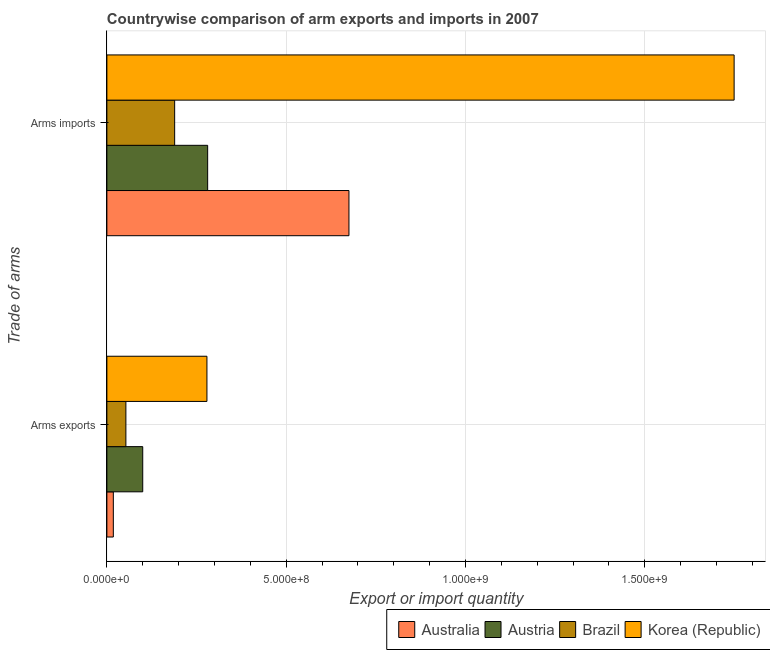How many different coloured bars are there?
Make the answer very short. 4. Are the number of bars on each tick of the Y-axis equal?
Ensure brevity in your answer.  Yes. What is the label of the 2nd group of bars from the top?
Your response must be concise. Arms exports. What is the arms imports in Australia?
Ensure brevity in your answer.  6.75e+08. Across all countries, what is the maximum arms exports?
Offer a terse response. 2.79e+08. Across all countries, what is the minimum arms imports?
Keep it short and to the point. 1.89e+08. What is the total arms imports in the graph?
Your answer should be compact. 2.89e+09. What is the difference between the arms imports in Brazil and that in Korea (Republic)?
Make the answer very short. -1.56e+09. What is the difference between the arms imports in Korea (Republic) and the arms exports in Brazil?
Your answer should be compact. 1.70e+09. What is the average arms exports per country?
Your answer should be compact. 1.12e+08. What is the difference between the arms imports and arms exports in Brazil?
Offer a terse response. 1.36e+08. In how many countries, is the arms exports greater than 1600000000 ?
Offer a terse response. 0. What is the ratio of the arms imports in Brazil to that in Austria?
Make the answer very short. 0.67. What does the 3rd bar from the top in Arms imports represents?
Provide a succinct answer. Austria. What does the 2nd bar from the bottom in Arms exports represents?
Keep it short and to the point. Austria. How many bars are there?
Offer a very short reply. 8. Are the values on the major ticks of X-axis written in scientific E-notation?
Offer a very short reply. Yes. Does the graph contain any zero values?
Ensure brevity in your answer.  No. Where does the legend appear in the graph?
Your answer should be compact. Bottom right. How are the legend labels stacked?
Your answer should be very brief. Horizontal. What is the title of the graph?
Provide a short and direct response. Countrywise comparison of arm exports and imports in 2007. What is the label or title of the X-axis?
Make the answer very short. Export or import quantity. What is the label or title of the Y-axis?
Offer a very short reply. Trade of arms. What is the Export or import quantity in Australia in Arms exports?
Your response must be concise. 1.80e+07. What is the Export or import quantity in Austria in Arms exports?
Offer a terse response. 1.00e+08. What is the Export or import quantity in Brazil in Arms exports?
Keep it short and to the point. 5.30e+07. What is the Export or import quantity in Korea (Republic) in Arms exports?
Your response must be concise. 2.79e+08. What is the Export or import quantity of Australia in Arms imports?
Keep it short and to the point. 6.75e+08. What is the Export or import quantity in Austria in Arms imports?
Your answer should be compact. 2.81e+08. What is the Export or import quantity of Brazil in Arms imports?
Offer a very short reply. 1.89e+08. What is the Export or import quantity in Korea (Republic) in Arms imports?
Offer a terse response. 1.75e+09. Across all Trade of arms, what is the maximum Export or import quantity in Australia?
Your answer should be compact. 6.75e+08. Across all Trade of arms, what is the maximum Export or import quantity of Austria?
Keep it short and to the point. 2.81e+08. Across all Trade of arms, what is the maximum Export or import quantity in Brazil?
Offer a very short reply. 1.89e+08. Across all Trade of arms, what is the maximum Export or import quantity of Korea (Republic)?
Ensure brevity in your answer.  1.75e+09. Across all Trade of arms, what is the minimum Export or import quantity of Australia?
Provide a succinct answer. 1.80e+07. Across all Trade of arms, what is the minimum Export or import quantity of Austria?
Offer a terse response. 1.00e+08. Across all Trade of arms, what is the minimum Export or import quantity of Brazil?
Offer a very short reply. 5.30e+07. Across all Trade of arms, what is the minimum Export or import quantity in Korea (Republic)?
Provide a succinct answer. 2.79e+08. What is the total Export or import quantity of Australia in the graph?
Provide a short and direct response. 6.93e+08. What is the total Export or import quantity of Austria in the graph?
Keep it short and to the point. 3.81e+08. What is the total Export or import quantity of Brazil in the graph?
Your answer should be very brief. 2.42e+08. What is the total Export or import quantity of Korea (Republic) in the graph?
Your answer should be compact. 2.03e+09. What is the difference between the Export or import quantity of Australia in Arms exports and that in Arms imports?
Keep it short and to the point. -6.57e+08. What is the difference between the Export or import quantity of Austria in Arms exports and that in Arms imports?
Your response must be concise. -1.81e+08. What is the difference between the Export or import quantity in Brazil in Arms exports and that in Arms imports?
Your answer should be very brief. -1.36e+08. What is the difference between the Export or import quantity in Korea (Republic) in Arms exports and that in Arms imports?
Offer a very short reply. -1.47e+09. What is the difference between the Export or import quantity of Australia in Arms exports and the Export or import quantity of Austria in Arms imports?
Make the answer very short. -2.63e+08. What is the difference between the Export or import quantity of Australia in Arms exports and the Export or import quantity of Brazil in Arms imports?
Offer a very short reply. -1.71e+08. What is the difference between the Export or import quantity of Australia in Arms exports and the Export or import quantity of Korea (Republic) in Arms imports?
Keep it short and to the point. -1.73e+09. What is the difference between the Export or import quantity of Austria in Arms exports and the Export or import quantity of Brazil in Arms imports?
Offer a very short reply. -8.90e+07. What is the difference between the Export or import quantity in Austria in Arms exports and the Export or import quantity in Korea (Republic) in Arms imports?
Your answer should be compact. -1.65e+09. What is the difference between the Export or import quantity of Brazil in Arms exports and the Export or import quantity of Korea (Republic) in Arms imports?
Your answer should be compact. -1.70e+09. What is the average Export or import quantity of Australia per Trade of arms?
Offer a very short reply. 3.46e+08. What is the average Export or import quantity in Austria per Trade of arms?
Your response must be concise. 1.90e+08. What is the average Export or import quantity of Brazil per Trade of arms?
Make the answer very short. 1.21e+08. What is the average Export or import quantity in Korea (Republic) per Trade of arms?
Provide a succinct answer. 1.01e+09. What is the difference between the Export or import quantity in Australia and Export or import quantity in Austria in Arms exports?
Your answer should be compact. -8.20e+07. What is the difference between the Export or import quantity of Australia and Export or import quantity of Brazil in Arms exports?
Offer a very short reply. -3.50e+07. What is the difference between the Export or import quantity of Australia and Export or import quantity of Korea (Republic) in Arms exports?
Your answer should be compact. -2.61e+08. What is the difference between the Export or import quantity of Austria and Export or import quantity of Brazil in Arms exports?
Offer a terse response. 4.70e+07. What is the difference between the Export or import quantity in Austria and Export or import quantity in Korea (Republic) in Arms exports?
Keep it short and to the point. -1.79e+08. What is the difference between the Export or import quantity of Brazil and Export or import quantity of Korea (Republic) in Arms exports?
Ensure brevity in your answer.  -2.26e+08. What is the difference between the Export or import quantity in Australia and Export or import quantity in Austria in Arms imports?
Ensure brevity in your answer.  3.94e+08. What is the difference between the Export or import quantity in Australia and Export or import quantity in Brazil in Arms imports?
Your answer should be very brief. 4.86e+08. What is the difference between the Export or import quantity in Australia and Export or import quantity in Korea (Republic) in Arms imports?
Your response must be concise. -1.07e+09. What is the difference between the Export or import quantity of Austria and Export or import quantity of Brazil in Arms imports?
Your answer should be very brief. 9.20e+07. What is the difference between the Export or import quantity in Austria and Export or import quantity in Korea (Republic) in Arms imports?
Your answer should be very brief. -1.47e+09. What is the difference between the Export or import quantity in Brazil and Export or import quantity in Korea (Republic) in Arms imports?
Make the answer very short. -1.56e+09. What is the ratio of the Export or import quantity of Australia in Arms exports to that in Arms imports?
Offer a terse response. 0.03. What is the ratio of the Export or import quantity in Austria in Arms exports to that in Arms imports?
Offer a very short reply. 0.36. What is the ratio of the Export or import quantity of Brazil in Arms exports to that in Arms imports?
Your answer should be compact. 0.28. What is the ratio of the Export or import quantity in Korea (Republic) in Arms exports to that in Arms imports?
Provide a succinct answer. 0.16. What is the difference between the highest and the second highest Export or import quantity in Australia?
Provide a short and direct response. 6.57e+08. What is the difference between the highest and the second highest Export or import quantity of Austria?
Your answer should be compact. 1.81e+08. What is the difference between the highest and the second highest Export or import quantity of Brazil?
Offer a terse response. 1.36e+08. What is the difference between the highest and the second highest Export or import quantity in Korea (Republic)?
Give a very brief answer. 1.47e+09. What is the difference between the highest and the lowest Export or import quantity of Australia?
Provide a succinct answer. 6.57e+08. What is the difference between the highest and the lowest Export or import quantity of Austria?
Make the answer very short. 1.81e+08. What is the difference between the highest and the lowest Export or import quantity of Brazil?
Offer a terse response. 1.36e+08. What is the difference between the highest and the lowest Export or import quantity in Korea (Republic)?
Ensure brevity in your answer.  1.47e+09. 